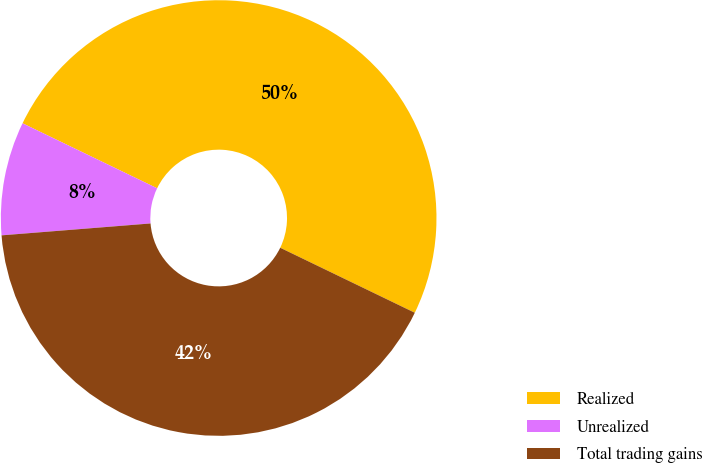Convert chart. <chart><loc_0><loc_0><loc_500><loc_500><pie_chart><fcel>Realized<fcel>Unrealized<fcel>Total trading gains<nl><fcel>50.0%<fcel>8.43%<fcel>41.57%<nl></chart> 